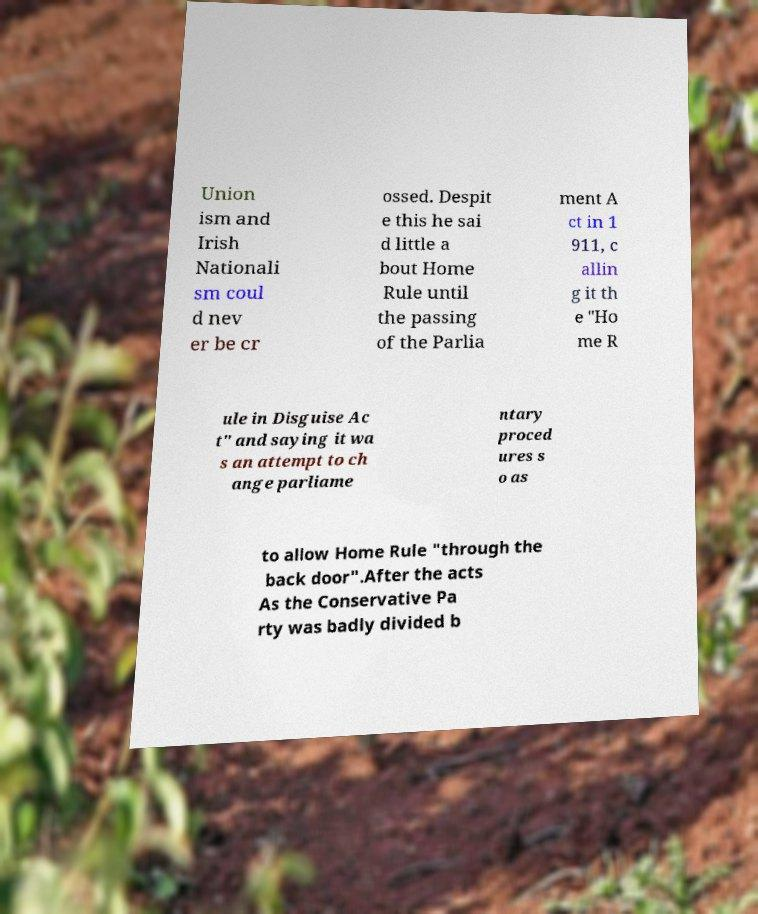Please read and relay the text visible in this image. What does it say? Union ism and Irish Nationali sm coul d nev er be cr ossed. Despit e this he sai d little a bout Home Rule until the passing of the Parlia ment A ct in 1 911, c allin g it th e "Ho me R ule in Disguise Ac t" and saying it wa s an attempt to ch ange parliame ntary proced ures s o as to allow Home Rule "through the back door".After the acts As the Conservative Pa rty was badly divided b 